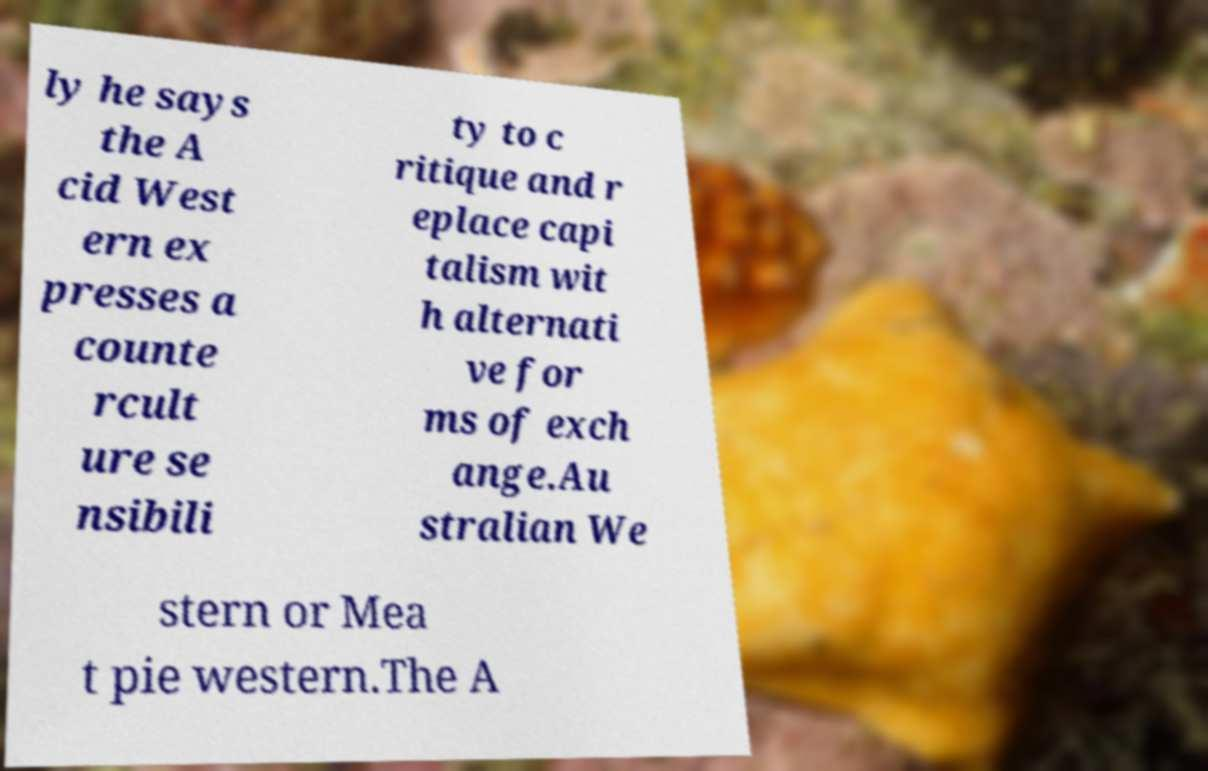Can you read and provide the text displayed in the image?This photo seems to have some interesting text. Can you extract and type it out for me? ly he says the A cid West ern ex presses a counte rcult ure se nsibili ty to c ritique and r eplace capi talism wit h alternati ve for ms of exch ange.Au stralian We stern or Mea t pie western.The A 